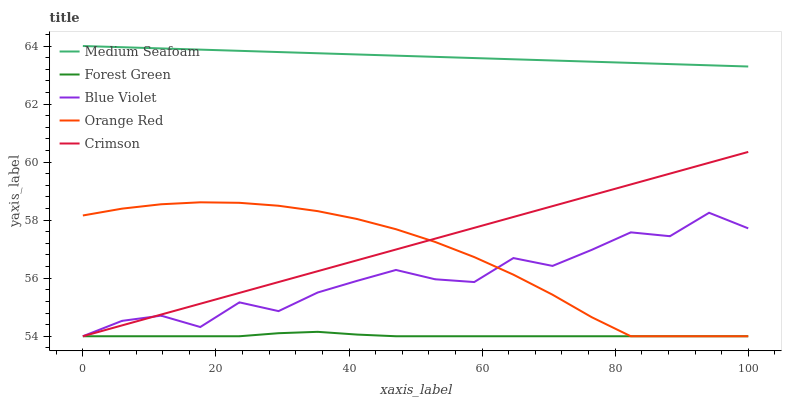Does Forest Green have the minimum area under the curve?
Answer yes or no. Yes. Does Medium Seafoam have the maximum area under the curve?
Answer yes or no. Yes. Does Medium Seafoam have the minimum area under the curve?
Answer yes or no. No. Does Forest Green have the maximum area under the curve?
Answer yes or no. No. Is Crimson the smoothest?
Answer yes or no. Yes. Is Blue Violet the roughest?
Answer yes or no. Yes. Is Forest Green the smoothest?
Answer yes or no. No. Is Forest Green the roughest?
Answer yes or no. No. Does Crimson have the lowest value?
Answer yes or no. Yes. Does Medium Seafoam have the lowest value?
Answer yes or no. No. Does Medium Seafoam have the highest value?
Answer yes or no. Yes. Does Forest Green have the highest value?
Answer yes or no. No. Is Forest Green less than Medium Seafoam?
Answer yes or no. Yes. Is Medium Seafoam greater than Crimson?
Answer yes or no. Yes. Does Forest Green intersect Orange Red?
Answer yes or no. Yes. Is Forest Green less than Orange Red?
Answer yes or no. No. Is Forest Green greater than Orange Red?
Answer yes or no. No. Does Forest Green intersect Medium Seafoam?
Answer yes or no. No. 